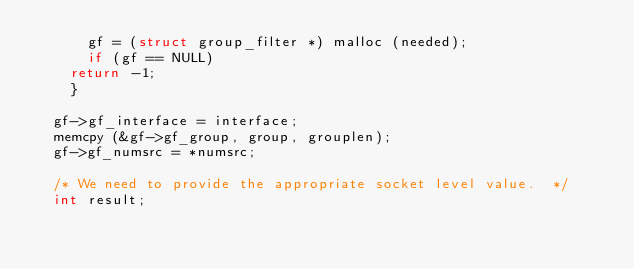<code> <loc_0><loc_0><loc_500><loc_500><_C_>      gf = (struct group_filter *) malloc (needed);
      if (gf == NULL)
	return -1;
    }

  gf->gf_interface = interface;
  memcpy (&gf->gf_group, group, grouplen);
  gf->gf_numsrc = *numsrc;

  /* We need to provide the appropriate socket level value.  */
  int result;</code> 